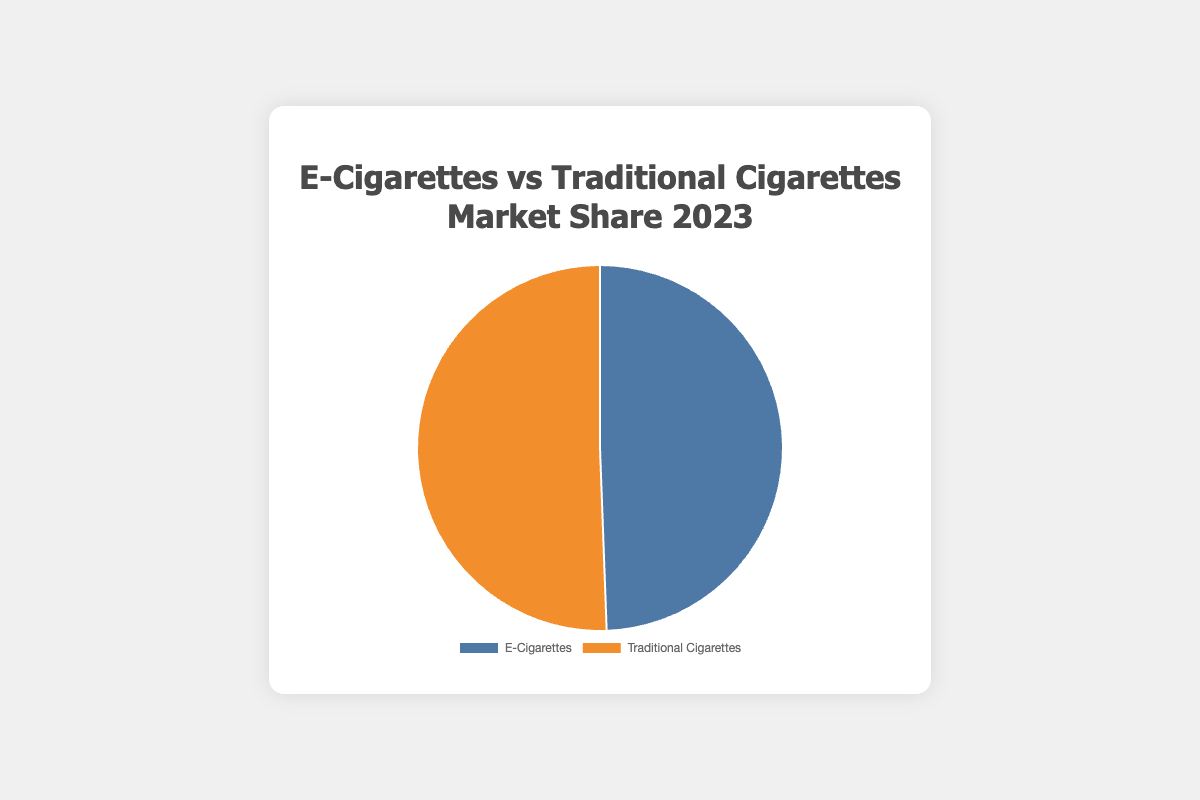What's the combined market share for e-cigarettes in 2023? Add up the market share percentages for all e-cigarette companies: 35.4 + 28.7 + 15.2 + 10.3 + 8.1 = 97.7%
Answer: 97.7% Which category has a higher total market share in 2023, e-cigarettes or traditional cigarettes? The chart shows that e-cigarettes have a market share of 97.7% and traditional cigarettes have a market share of 100%. Since 100% is greater than 97.7%, traditional cigarettes have a higher total market share.
Answer: Traditional cigarettes Which company has the largest share in the e-cigarette market? From the data, JUUL Labs has the highest percentage in the e-cigarette category with 35.4%.
Answer: JUUL Labs How much larger is the market share of JUUL Labs compared to NJOY in the e-cigarette market? Subtract NJOY's market share from JUUL Labs' market share: 35.4 - 15.2 = 20.2%
Answer: 20.2% What is the visual indication of the market share difference between the two categories in the pie chart? The section representing traditional cigarettes (orange) is slightly larger than the section representing e-cigarettes (blue) on the pie chart.
Answer: Traditional cigarettes section is larger What is the average market share of traditional cigarette companies in 2023? Add up the market share percentages for all traditional cigarette companies and divide by the number of companies: (26.7 + 20.4 + 14.8 + 12.6 + 25.5) / 5 = 20%
Answer: 20% Which company has the smallest market share among all listed companies? From the data, Relx in the e-cigarette category has the smallest market share with 8.1%.
Answer: Relx By how much does Philip Morris International's market share exceed British American Tobacco in the traditional cigarette market? Subtract British American Tobacco's market share from Philip Morris International's market share: 26.7 - 20.4 = 6.3%
Answer: 6.3% What is the sum of the market shares of the companies under Imperial Brands in both categories? Add up the market share of Imperial Brands in e-cigarettes and traditional cigarettes: 10.3% + 12.6% = 22.9%
Answer: 22.9% Which category has a more dominant leading company, based on market share percentage? Compare the top company market shares: JUUL Labs (35.4%) in e-cigarettes is higher than Philip Morris International (26.7%) in traditional cigarettes.
Answer: E-cigarettes 